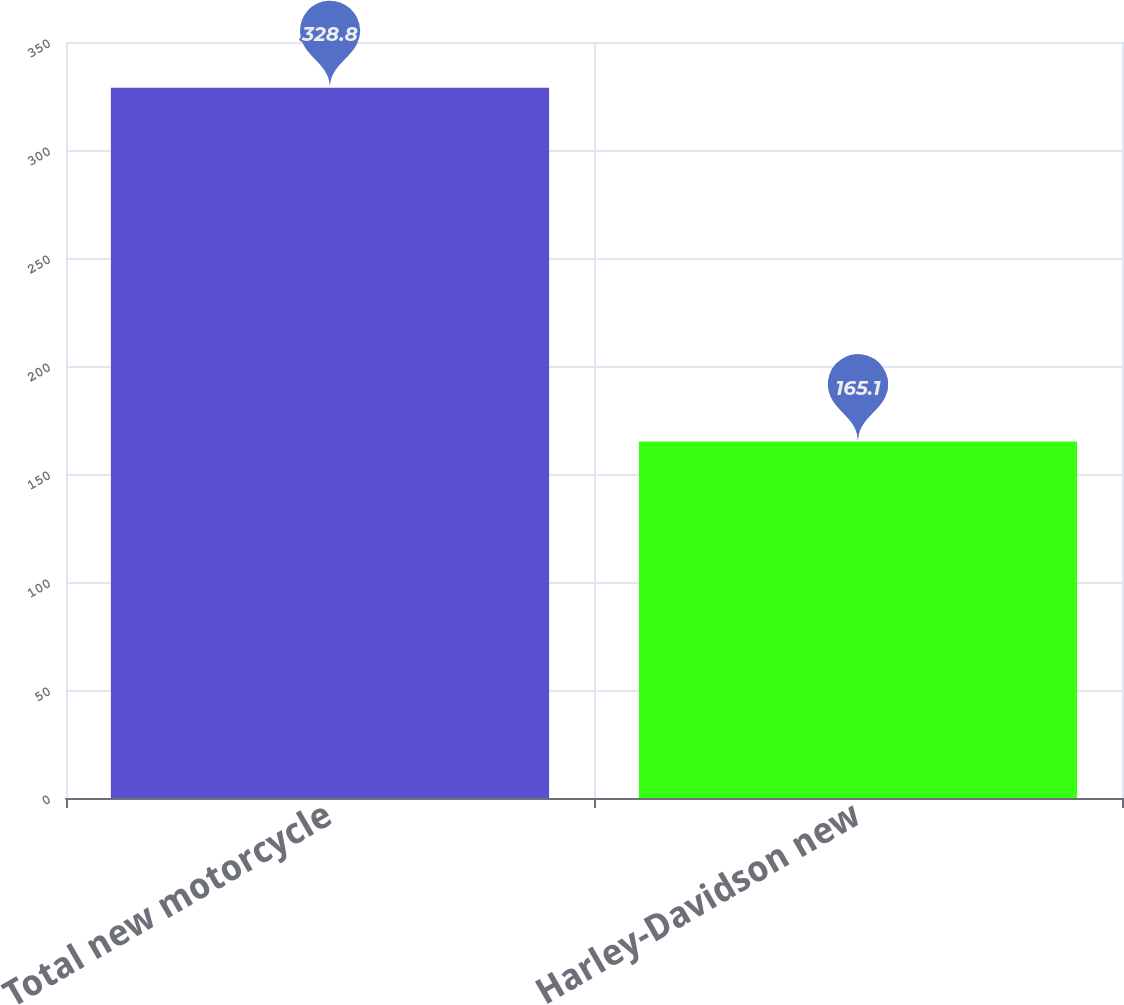Convert chart. <chart><loc_0><loc_0><loc_500><loc_500><bar_chart><fcel>Total new motorcycle<fcel>Harley-Davidson new<nl><fcel>328.8<fcel>165.1<nl></chart> 